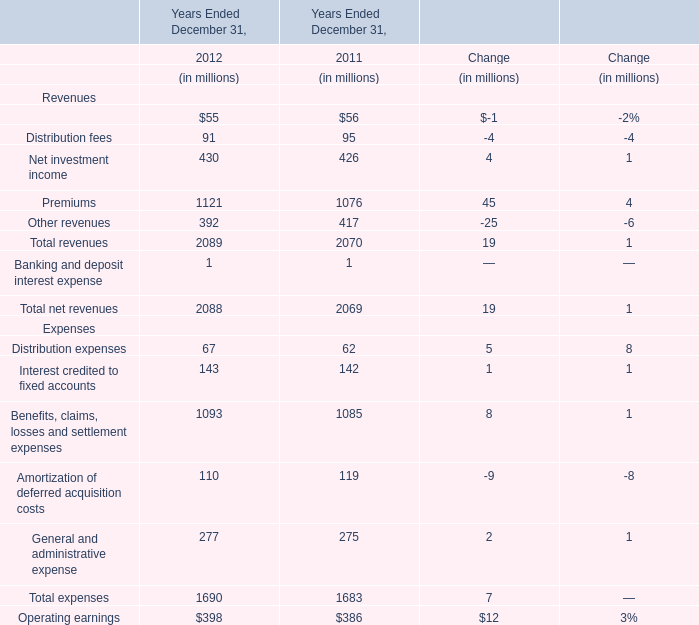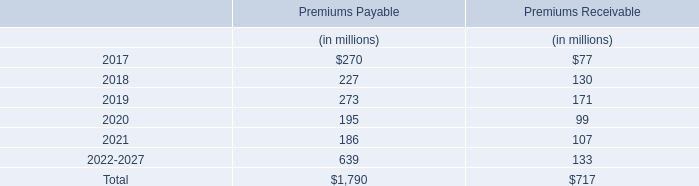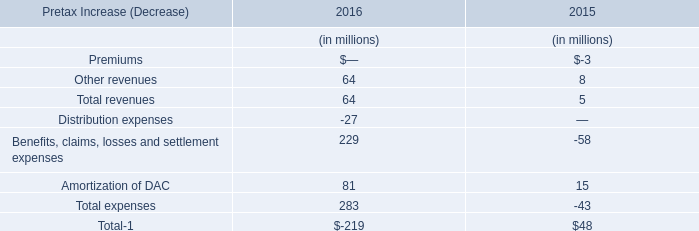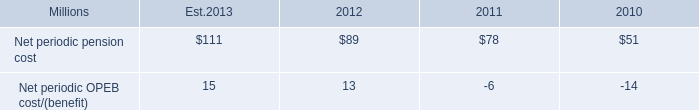what is the estimated growth rate in net periodic pension cost from 2012 to 2013? 
Computations: ((111 - 89) / 89)
Answer: 0.24719. 